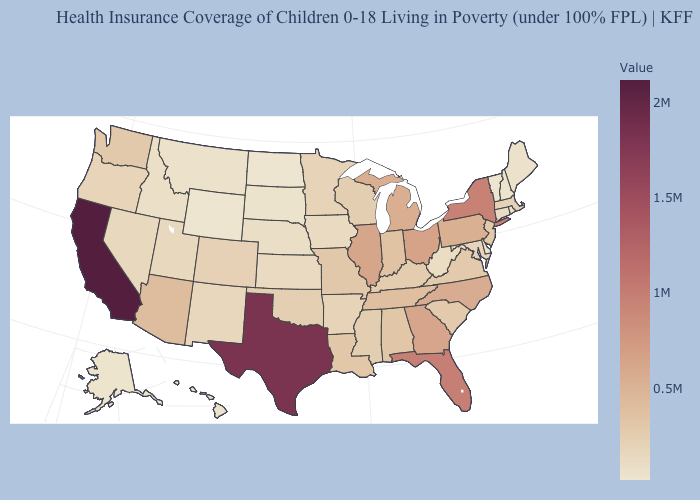Among the states that border Texas , does Louisiana have the lowest value?
Short answer required. No. Among the states that border Massachusetts , which have the lowest value?
Write a very short answer. Vermont. Does Wyoming have the lowest value in the USA?
Concise answer only. Yes. Does the map have missing data?
Concise answer only. No. 